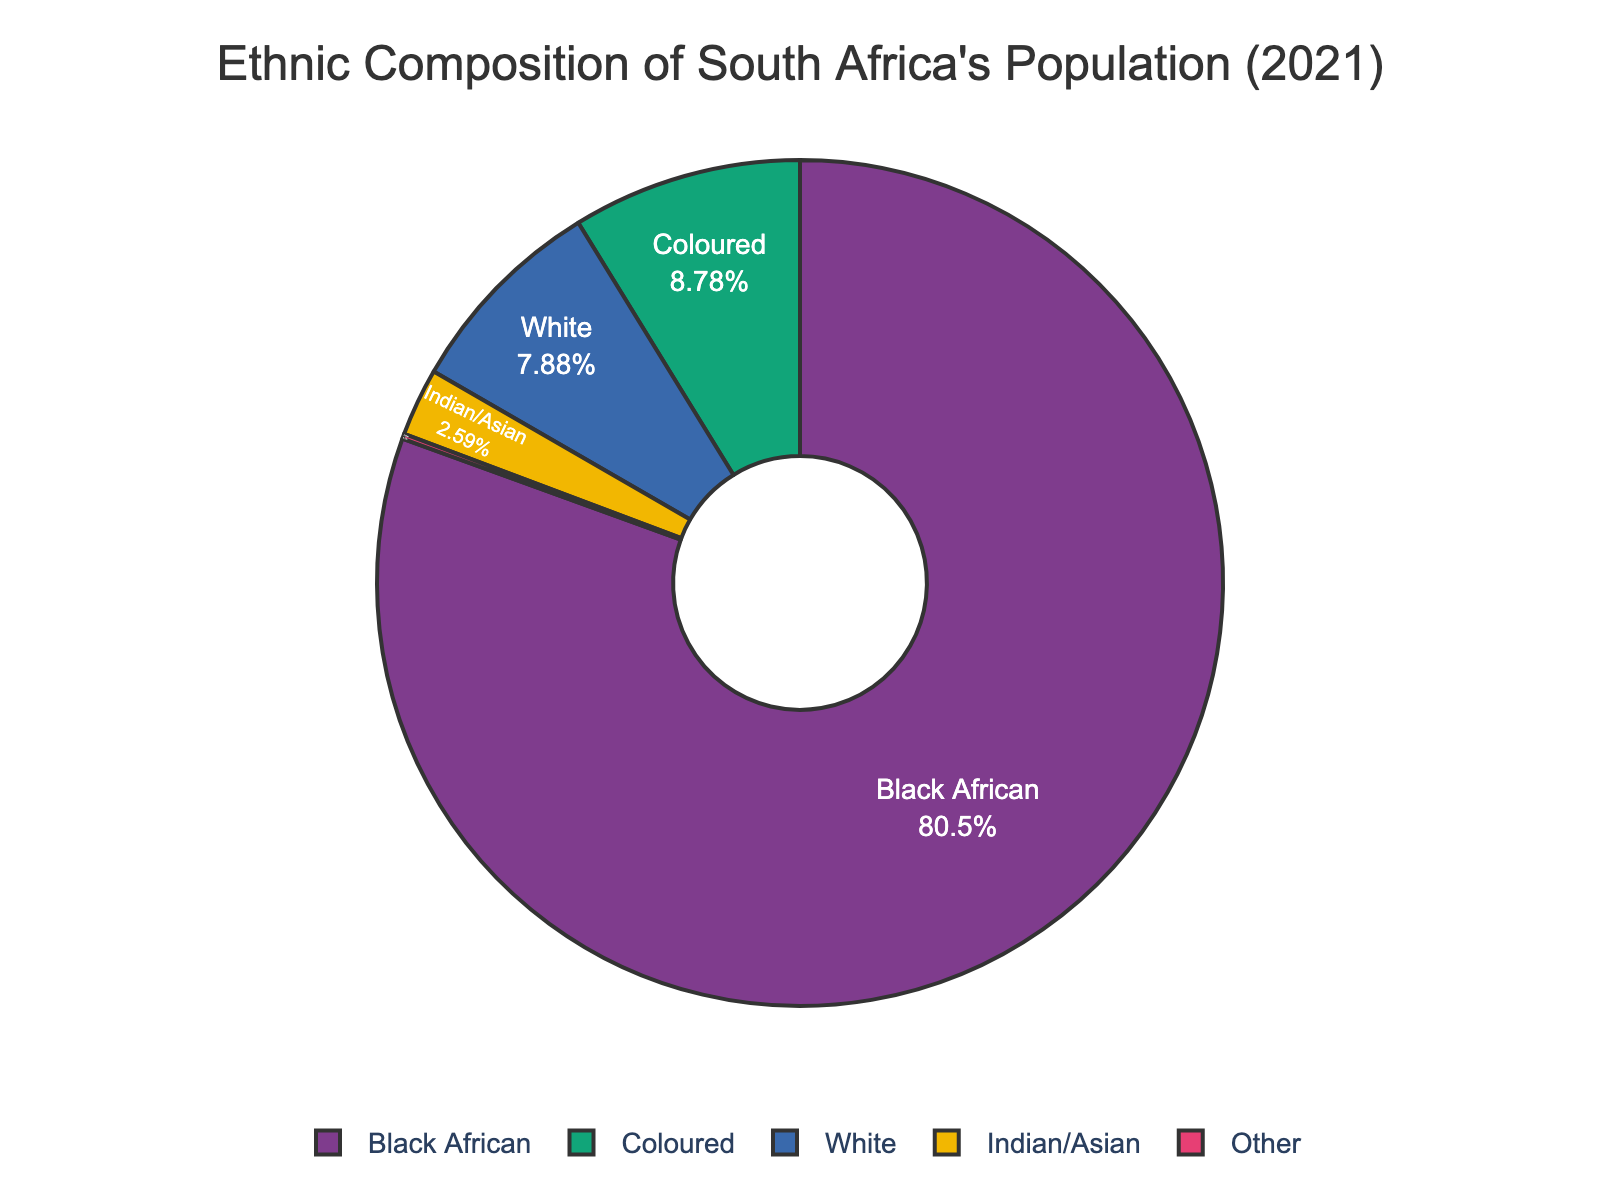What percentage of the population is Black African? By looking at the pie chart, find the slice labeled "Black African" and note its percentage value. Black African accounts for 80.7% of the population.
Answer: 80.7% Compare the sizes of the 'White' and 'Coloured' populations. Which is larger? Locate the slices labeled "White" and "Coloured" in the pie chart. Compare their sizes based on the percentages. The "Coloured" population (8.8%) is larger than the "White" population (7.9%).
Answer: Coloured What is the sum of the percentages of the 'Indian/Asian' and 'Other' populations? Find the slices labeled "Indian/Asian" and "Other" and note their percentages. Add these two values together: 2.6% + 0.2% = 2.8%.
Answer: 2.8% How much larger is the 'Black African' population than the 'White' population in percentage terms? Determine the percentages for the 'Black African' (80.7%) and 'White' (7.9%) populations. Subtract the percentage of the 'White' population from the 'Black African' population: 80.7% - 7.9% = 72.8%.
Answer: 72.8% Which ethnic group has the smallest population percentage? Identify the smallest slice in the pie chart. The slice labeled "Other" is the smallest, with a population percentage of 0.2%.
Answer: Other What is the average percentage of the 'White' and 'Coloured' populations? Find the percentages for 'White' (7.9%) and 'Coloured' (8.8%). Calculate the average by adding these percentages and dividing by 2: (7.9% + 8.8%) / 2 = 8.35%.
Answer: 8.35% If you sum up the percentages of 'White’, ‘Coloured’, and ‘Indian/Asian’, what do you get? Find the percentages for 'White' (7.9%), 'Coloured' (8.8%), and 'Indian/Asian' (2.6%). Add them together: 7.9% + 8.8% + 2.6% = 19.3%.
Answer: 19.3% What color represents the 'Other' ethnic group in the pie chart? Locate the slice labeled "Other" and identify its color. As the pie chart uses a predefined color sequence, the 'Other' slice is grey.
Answer: grey How do the visual sizes of the 'Black African' and 'Indian/Asian' slices compare? Look at the relative sizes of the slices for 'Black African' and 'Indian/Asian'. The 'Black African' slice is much larger than the 'Indian/Asian' slice.
Answer: Black African slice is much larger 